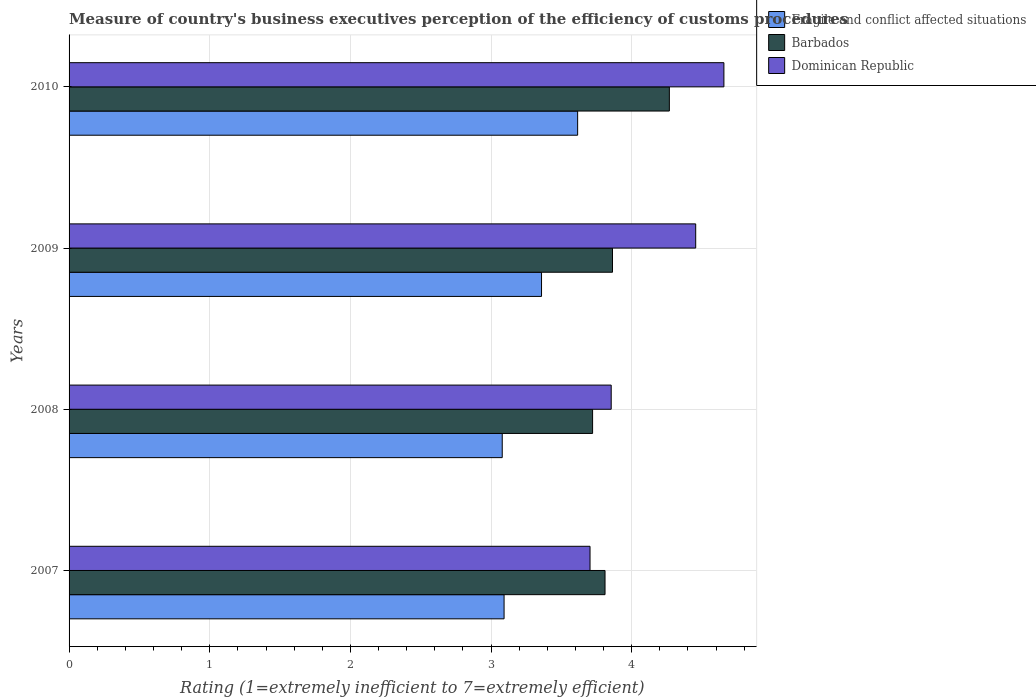How many different coloured bars are there?
Provide a succinct answer. 3. How many groups of bars are there?
Your answer should be very brief. 4. Are the number of bars per tick equal to the number of legend labels?
Give a very brief answer. Yes. How many bars are there on the 2nd tick from the bottom?
Offer a very short reply. 3. What is the label of the 4th group of bars from the top?
Make the answer very short. 2007. What is the rating of the efficiency of customs procedure in Fragile and conflict affected situations in 2009?
Offer a very short reply. 3.36. Across all years, what is the maximum rating of the efficiency of customs procedure in Dominican Republic?
Make the answer very short. 4.66. Across all years, what is the minimum rating of the efficiency of customs procedure in Fragile and conflict affected situations?
Ensure brevity in your answer.  3.08. What is the total rating of the efficiency of customs procedure in Barbados in the graph?
Your answer should be compact. 15.66. What is the difference between the rating of the efficiency of customs procedure in Barbados in 2009 and that in 2010?
Give a very brief answer. -0.4. What is the difference between the rating of the efficiency of customs procedure in Fragile and conflict affected situations in 2010 and the rating of the efficiency of customs procedure in Barbados in 2007?
Ensure brevity in your answer.  -0.19. What is the average rating of the efficiency of customs procedure in Fragile and conflict affected situations per year?
Your answer should be very brief. 3.29. In the year 2010, what is the difference between the rating of the efficiency of customs procedure in Barbados and rating of the efficiency of customs procedure in Dominican Republic?
Keep it short and to the point. -0.39. What is the ratio of the rating of the efficiency of customs procedure in Dominican Republic in 2008 to that in 2010?
Your response must be concise. 0.83. Is the rating of the efficiency of customs procedure in Fragile and conflict affected situations in 2008 less than that in 2010?
Your answer should be compact. Yes. Is the difference between the rating of the efficiency of customs procedure in Barbados in 2007 and 2010 greater than the difference between the rating of the efficiency of customs procedure in Dominican Republic in 2007 and 2010?
Provide a succinct answer. Yes. What is the difference between the highest and the second highest rating of the efficiency of customs procedure in Barbados?
Ensure brevity in your answer.  0.4. What is the difference between the highest and the lowest rating of the efficiency of customs procedure in Fragile and conflict affected situations?
Provide a succinct answer. 0.54. In how many years, is the rating of the efficiency of customs procedure in Fragile and conflict affected situations greater than the average rating of the efficiency of customs procedure in Fragile and conflict affected situations taken over all years?
Provide a short and direct response. 2. Is the sum of the rating of the efficiency of customs procedure in Barbados in 2008 and 2009 greater than the maximum rating of the efficiency of customs procedure in Dominican Republic across all years?
Your answer should be compact. Yes. What does the 3rd bar from the top in 2009 represents?
Your answer should be very brief. Fragile and conflict affected situations. What does the 2nd bar from the bottom in 2007 represents?
Keep it short and to the point. Barbados. Is it the case that in every year, the sum of the rating of the efficiency of customs procedure in Barbados and rating of the efficiency of customs procedure in Fragile and conflict affected situations is greater than the rating of the efficiency of customs procedure in Dominican Republic?
Make the answer very short. Yes. Are all the bars in the graph horizontal?
Your answer should be compact. Yes. What is the difference between two consecutive major ticks on the X-axis?
Keep it short and to the point. 1. Are the values on the major ticks of X-axis written in scientific E-notation?
Your answer should be very brief. No. Does the graph contain any zero values?
Provide a short and direct response. No. Where does the legend appear in the graph?
Offer a very short reply. Top right. How many legend labels are there?
Offer a terse response. 3. What is the title of the graph?
Your answer should be very brief. Measure of country's business executives perception of the efficiency of customs procedures. Does "Cameroon" appear as one of the legend labels in the graph?
Your response must be concise. No. What is the label or title of the X-axis?
Offer a very short reply. Rating (1=extremely inefficient to 7=extremely efficient). What is the label or title of the Y-axis?
Offer a terse response. Years. What is the Rating (1=extremely inefficient to 7=extremely efficient) in Fragile and conflict affected situations in 2007?
Offer a very short reply. 3.09. What is the Rating (1=extremely inefficient to 7=extremely efficient) in Barbados in 2007?
Offer a terse response. 3.81. What is the Rating (1=extremely inefficient to 7=extremely efficient) of Dominican Republic in 2007?
Ensure brevity in your answer.  3.7. What is the Rating (1=extremely inefficient to 7=extremely efficient) of Fragile and conflict affected situations in 2008?
Offer a terse response. 3.08. What is the Rating (1=extremely inefficient to 7=extremely efficient) of Barbados in 2008?
Your answer should be compact. 3.72. What is the Rating (1=extremely inefficient to 7=extremely efficient) of Dominican Republic in 2008?
Your answer should be compact. 3.85. What is the Rating (1=extremely inefficient to 7=extremely efficient) in Fragile and conflict affected situations in 2009?
Provide a short and direct response. 3.36. What is the Rating (1=extremely inefficient to 7=extremely efficient) of Barbados in 2009?
Provide a succinct answer. 3.86. What is the Rating (1=extremely inefficient to 7=extremely efficient) of Dominican Republic in 2009?
Give a very brief answer. 4.46. What is the Rating (1=extremely inefficient to 7=extremely efficient) in Fragile and conflict affected situations in 2010?
Offer a very short reply. 3.62. What is the Rating (1=extremely inefficient to 7=extremely efficient) in Barbados in 2010?
Keep it short and to the point. 4.27. What is the Rating (1=extremely inefficient to 7=extremely efficient) of Dominican Republic in 2010?
Offer a terse response. 4.66. Across all years, what is the maximum Rating (1=extremely inefficient to 7=extremely efficient) in Fragile and conflict affected situations?
Your answer should be very brief. 3.62. Across all years, what is the maximum Rating (1=extremely inefficient to 7=extremely efficient) of Barbados?
Offer a terse response. 4.27. Across all years, what is the maximum Rating (1=extremely inefficient to 7=extremely efficient) of Dominican Republic?
Provide a short and direct response. 4.66. Across all years, what is the minimum Rating (1=extremely inefficient to 7=extremely efficient) in Fragile and conflict affected situations?
Keep it short and to the point. 3.08. Across all years, what is the minimum Rating (1=extremely inefficient to 7=extremely efficient) in Barbados?
Your response must be concise. 3.72. Across all years, what is the minimum Rating (1=extremely inefficient to 7=extremely efficient) of Dominican Republic?
Ensure brevity in your answer.  3.7. What is the total Rating (1=extremely inefficient to 7=extremely efficient) in Fragile and conflict affected situations in the graph?
Offer a terse response. 13.15. What is the total Rating (1=extremely inefficient to 7=extremely efficient) of Barbados in the graph?
Keep it short and to the point. 15.66. What is the total Rating (1=extremely inefficient to 7=extremely efficient) of Dominican Republic in the graph?
Give a very brief answer. 16.67. What is the difference between the Rating (1=extremely inefficient to 7=extremely efficient) of Fragile and conflict affected situations in 2007 and that in 2008?
Provide a short and direct response. 0.01. What is the difference between the Rating (1=extremely inefficient to 7=extremely efficient) of Barbados in 2007 and that in 2008?
Your response must be concise. 0.09. What is the difference between the Rating (1=extremely inefficient to 7=extremely efficient) in Dominican Republic in 2007 and that in 2008?
Provide a short and direct response. -0.15. What is the difference between the Rating (1=extremely inefficient to 7=extremely efficient) in Fragile and conflict affected situations in 2007 and that in 2009?
Offer a terse response. -0.27. What is the difference between the Rating (1=extremely inefficient to 7=extremely efficient) in Barbados in 2007 and that in 2009?
Make the answer very short. -0.05. What is the difference between the Rating (1=extremely inefficient to 7=extremely efficient) in Dominican Republic in 2007 and that in 2009?
Your response must be concise. -0.75. What is the difference between the Rating (1=extremely inefficient to 7=extremely efficient) of Fragile and conflict affected situations in 2007 and that in 2010?
Provide a short and direct response. -0.52. What is the difference between the Rating (1=extremely inefficient to 7=extremely efficient) of Barbados in 2007 and that in 2010?
Ensure brevity in your answer.  -0.46. What is the difference between the Rating (1=extremely inefficient to 7=extremely efficient) in Dominican Republic in 2007 and that in 2010?
Offer a very short reply. -0.95. What is the difference between the Rating (1=extremely inefficient to 7=extremely efficient) of Fragile and conflict affected situations in 2008 and that in 2009?
Offer a very short reply. -0.28. What is the difference between the Rating (1=extremely inefficient to 7=extremely efficient) in Barbados in 2008 and that in 2009?
Give a very brief answer. -0.14. What is the difference between the Rating (1=extremely inefficient to 7=extremely efficient) of Dominican Republic in 2008 and that in 2009?
Your answer should be compact. -0.6. What is the difference between the Rating (1=extremely inefficient to 7=extremely efficient) in Fragile and conflict affected situations in 2008 and that in 2010?
Your answer should be very brief. -0.54. What is the difference between the Rating (1=extremely inefficient to 7=extremely efficient) of Barbados in 2008 and that in 2010?
Ensure brevity in your answer.  -0.55. What is the difference between the Rating (1=extremely inefficient to 7=extremely efficient) in Dominican Republic in 2008 and that in 2010?
Your response must be concise. -0.8. What is the difference between the Rating (1=extremely inefficient to 7=extremely efficient) in Fragile and conflict affected situations in 2009 and that in 2010?
Give a very brief answer. -0.26. What is the difference between the Rating (1=extremely inefficient to 7=extremely efficient) of Barbados in 2009 and that in 2010?
Make the answer very short. -0.4. What is the difference between the Rating (1=extremely inefficient to 7=extremely efficient) in Dominican Republic in 2009 and that in 2010?
Provide a short and direct response. -0.2. What is the difference between the Rating (1=extremely inefficient to 7=extremely efficient) of Fragile and conflict affected situations in 2007 and the Rating (1=extremely inefficient to 7=extremely efficient) of Barbados in 2008?
Make the answer very short. -0.63. What is the difference between the Rating (1=extremely inefficient to 7=extremely efficient) in Fragile and conflict affected situations in 2007 and the Rating (1=extremely inefficient to 7=extremely efficient) in Dominican Republic in 2008?
Give a very brief answer. -0.76. What is the difference between the Rating (1=extremely inefficient to 7=extremely efficient) in Barbados in 2007 and the Rating (1=extremely inefficient to 7=extremely efficient) in Dominican Republic in 2008?
Your answer should be compact. -0.04. What is the difference between the Rating (1=extremely inefficient to 7=extremely efficient) of Fragile and conflict affected situations in 2007 and the Rating (1=extremely inefficient to 7=extremely efficient) of Barbados in 2009?
Give a very brief answer. -0.77. What is the difference between the Rating (1=extremely inefficient to 7=extremely efficient) in Fragile and conflict affected situations in 2007 and the Rating (1=extremely inefficient to 7=extremely efficient) in Dominican Republic in 2009?
Your answer should be very brief. -1.36. What is the difference between the Rating (1=extremely inefficient to 7=extremely efficient) in Barbados in 2007 and the Rating (1=extremely inefficient to 7=extremely efficient) in Dominican Republic in 2009?
Your response must be concise. -0.64. What is the difference between the Rating (1=extremely inefficient to 7=extremely efficient) in Fragile and conflict affected situations in 2007 and the Rating (1=extremely inefficient to 7=extremely efficient) in Barbados in 2010?
Ensure brevity in your answer.  -1.18. What is the difference between the Rating (1=extremely inefficient to 7=extremely efficient) in Fragile and conflict affected situations in 2007 and the Rating (1=extremely inefficient to 7=extremely efficient) in Dominican Republic in 2010?
Give a very brief answer. -1.56. What is the difference between the Rating (1=extremely inefficient to 7=extremely efficient) in Barbados in 2007 and the Rating (1=extremely inefficient to 7=extremely efficient) in Dominican Republic in 2010?
Ensure brevity in your answer.  -0.85. What is the difference between the Rating (1=extremely inefficient to 7=extremely efficient) in Fragile and conflict affected situations in 2008 and the Rating (1=extremely inefficient to 7=extremely efficient) in Barbados in 2009?
Keep it short and to the point. -0.78. What is the difference between the Rating (1=extremely inefficient to 7=extremely efficient) of Fragile and conflict affected situations in 2008 and the Rating (1=extremely inefficient to 7=extremely efficient) of Dominican Republic in 2009?
Make the answer very short. -1.38. What is the difference between the Rating (1=extremely inefficient to 7=extremely efficient) in Barbados in 2008 and the Rating (1=extremely inefficient to 7=extremely efficient) in Dominican Republic in 2009?
Your answer should be very brief. -0.73. What is the difference between the Rating (1=extremely inefficient to 7=extremely efficient) in Fragile and conflict affected situations in 2008 and the Rating (1=extremely inefficient to 7=extremely efficient) in Barbados in 2010?
Ensure brevity in your answer.  -1.19. What is the difference between the Rating (1=extremely inefficient to 7=extremely efficient) in Fragile and conflict affected situations in 2008 and the Rating (1=extremely inefficient to 7=extremely efficient) in Dominican Republic in 2010?
Offer a very short reply. -1.58. What is the difference between the Rating (1=extremely inefficient to 7=extremely efficient) of Barbados in 2008 and the Rating (1=extremely inefficient to 7=extremely efficient) of Dominican Republic in 2010?
Offer a terse response. -0.93. What is the difference between the Rating (1=extremely inefficient to 7=extremely efficient) of Fragile and conflict affected situations in 2009 and the Rating (1=extremely inefficient to 7=extremely efficient) of Barbados in 2010?
Ensure brevity in your answer.  -0.91. What is the difference between the Rating (1=extremely inefficient to 7=extremely efficient) in Fragile and conflict affected situations in 2009 and the Rating (1=extremely inefficient to 7=extremely efficient) in Dominican Republic in 2010?
Ensure brevity in your answer.  -1.3. What is the difference between the Rating (1=extremely inefficient to 7=extremely efficient) of Barbados in 2009 and the Rating (1=extremely inefficient to 7=extremely efficient) of Dominican Republic in 2010?
Keep it short and to the point. -0.79. What is the average Rating (1=extremely inefficient to 7=extremely efficient) of Fragile and conflict affected situations per year?
Offer a terse response. 3.29. What is the average Rating (1=extremely inefficient to 7=extremely efficient) of Barbados per year?
Ensure brevity in your answer.  3.92. What is the average Rating (1=extremely inefficient to 7=extremely efficient) of Dominican Republic per year?
Your answer should be very brief. 4.17. In the year 2007, what is the difference between the Rating (1=extremely inefficient to 7=extremely efficient) of Fragile and conflict affected situations and Rating (1=extremely inefficient to 7=extremely efficient) of Barbados?
Your response must be concise. -0.72. In the year 2007, what is the difference between the Rating (1=extremely inefficient to 7=extremely efficient) in Fragile and conflict affected situations and Rating (1=extremely inefficient to 7=extremely efficient) in Dominican Republic?
Give a very brief answer. -0.61. In the year 2007, what is the difference between the Rating (1=extremely inefficient to 7=extremely efficient) of Barbados and Rating (1=extremely inefficient to 7=extremely efficient) of Dominican Republic?
Give a very brief answer. 0.11. In the year 2008, what is the difference between the Rating (1=extremely inefficient to 7=extremely efficient) in Fragile and conflict affected situations and Rating (1=extremely inefficient to 7=extremely efficient) in Barbados?
Offer a terse response. -0.64. In the year 2008, what is the difference between the Rating (1=extremely inefficient to 7=extremely efficient) in Fragile and conflict affected situations and Rating (1=extremely inefficient to 7=extremely efficient) in Dominican Republic?
Give a very brief answer. -0.77. In the year 2008, what is the difference between the Rating (1=extremely inefficient to 7=extremely efficient) in Barbados and Rating (1=extremely inefficient to 7=extremely efficient) in Dominican Republic?
Keep it short and to the point. -0.13. In the year 2009, what is the difference between the Rating (1=extremely inefficient to 7=extremely efficient) of Fragile and conflict affected situations and Rating (1=extremely inefficient to 7=extremely efficient) of Barbados?
Ensure brevity in your answer.  -0.5. In the year 2009, what is the difference between the Rating (1=extremely inefficient to 7=extremely efficient) in Fragile and conflict affected situations and Rating (1=extremely inefficient to 7=extremely efficient) in Dominican Republic?
Ensure brevity in your answer.  -1.1. In the year 2009, what is the difference between the Rating (1=extremely inefficient to 7=extremely efficient) in Barbados and Rating (1=extremely inefficient to 7=extremely efficient) in Dominican Republic?
Your answer should be compact. -0.59. In the year 2010, what is the difference between the Rating (1=extremely inefficient to 7=extremely efficient) in Fragile and conflict affected situations and Rating (1=extremely inefficient to 7=extremely efficient) in Barbados?
Make the answer very short. -0.65. In the year 2010, what is the difference between the Rating (1=extremely inefficient to 7=extremely efficient) of Fragile and conflict affected situations and Rating (1=extremely inefficient to 7=extremely efficient) of Dominican Republic?
Make the answer very short. -1.04. In the year 2010, what is the difference between the Rating (1=extremely inefficient to 7=extremely efficient) of Barbados and Rating (1=extremely inefficient to 7=extremely efficient) of Dominican Republic?
Provide a short and direct response. -0.39. What is the ratio of the Rating (1=extremely inefficient to 7=extremely efficient) in Barbados in 2007 to that in 2008?
Give a very brief answer. 1.02. What is the ratio of the Rating (1=extremely inefficient to 7=extremely efficient) in Dominican Republic in 2007 to that in 2008?
Your response must be concise. 0.96. What is the ratio of the Rating (1=extremely inefficient to 7=extremely efficient) of Fragile and conflict affected situations in 2007 to that in 2009?
Give a very brief answer. 0.92. What is the ratio of the Rating (1=extremely inefficient to 7=extremely efficient) in Barbados in 2007 to that in 2009?
Ensure brevity in your answer.  0.99. What is the ratio of the Rating (1=extremely inefficient to 7=extremely efficient) of Dominican Republic in 2007 to that in 2009?
Provide a succinct answer. 0.83. What is the ratio of the Rating (1=extremely inefficient to 7=extremely efficient) in Fragile and conflict affected situations in 2007 to that in 2010?
Provide a short and direct response. 0.86. What is the ratio of the Rating (1=extremely inefficient to 7=extremely efficient) of Barbados in 2007 to that in 2010?
Provide a short and direct response. 0.89. What is the ratio of the Rating (1=extremely inefficient to 7=extremely efficient) of Dominican Republic in 2007 to that in 2010?
Provide a short and direct response. 0.8. What is the ratio of the Rating (1=extremely inefficient to 7=extremely efficient) in Fragile and conflict affected situations in 2008 to that in 2009?
Make the answer very short. 0.92. What is the ratio of the Rating (1=extremely inefficient to 7=extremely efficient) of Barbados in 2008 to that in 2009?
Offer a terse response. 0.96. What is the ratio of the Rating (1=extremely inefficient to 7=extremely efficient) of Dominican Republic in 2008 to that in 2009?
Your response must be concise. 0.87. What is the ratio of the Rating (1=extremely inefficient to 7=extremely efficient) of Fragile and conflict affected situations in 2008 to that in 2010?
Offer a very short reply. 0.85. What is the ratio of the Rating (1=extremely inefficient to 7=extremely efficient) of Barbados in 2008 to that in 2010?
Offer a terse response. 0.87. What is the ratio of the Rating (1=extremely inefficient to 7=extremely efficient) of Dominican Republic in 2008 to that in 2010?
Give a very brief answer. 0.83. What is the ratio of the Rating (1=extremely inefficient to 7=extremely efficient) in Fragile and conflict affected situations in 2009 to that in 2010?
Provide a short and direct response. 0.93. What is the ratio of the Rating (1=extremely inefficient to 7=extremely efficient) of Barbados in 2009 to that in 2010?
Provide a succinct answer. 0.91. What is the ratio of the Rating (1=extremely inefficient to 7=extremely efficient) in Dominican Republic in 2009 to that in 2010?
Your answer should be compact. 0.96. What is the difference between the highest and the second highest Rating (1=extremely inefficient to 7=extremely efficient) of Fragile and conflict affected situations?
Offer a terse response. 0.26. What is the difference between the highest and the second highest Rating (1=extremely inefficient to 7=extremely efficient) in Barbados?
Ensure brevity in your answer.  0.4. What is the difference between the highest and the second highest Rating (1=extremely inefficient to 7=extremely efficient) of Dominican Republic?
Provide a succinct answer. 0.2. What is the difference between the highest and the lowest Rating (1=extremely inefficient to 7=extremely efficient) of Fragile and conflict affected situations?
Keep it short and to the point. 0.54. What is the difference between the highest and the lowest Rating (1=extremely inefficient to 7=extremely efficient) of Barbados?
Offer a terse response. 0.55. What is the difference between the highest and the lowest Rating (1=extremely inefficient to 7=extremely efficient) in Dominican Republic?
Offer a very short reply. 0.95. 